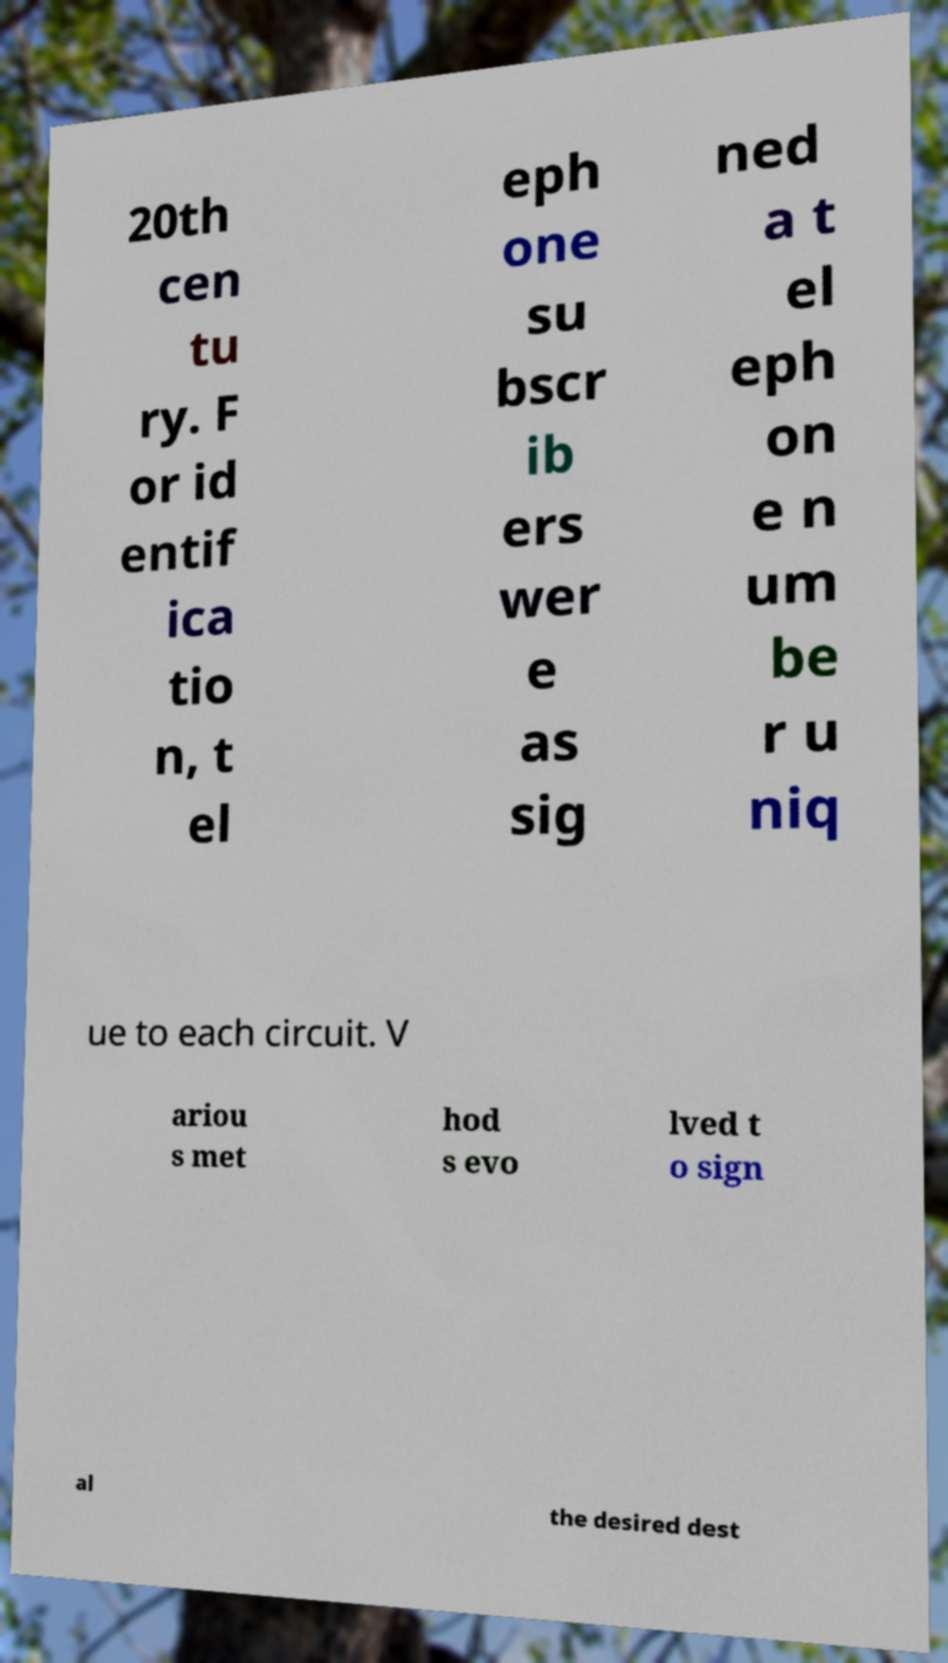There's text embedded in this image that I need extracted. Can you transcribe it verbatim? 20th cen tu ry. F or id entif ica tio n, t el eph one su bscr ib ers wer e as sig ned a t el eph on e n um be r u niq ue to each circuit. V ariou s met hod s evo lved t o sign al the desired dest 